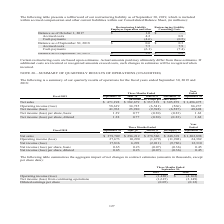According to Cubic's financial document, Where is the restructuring liability included within? accrued compensation and other current liabilities within our Consolidated Balance Sheet, (in millions). The document states: "as of September 30, 2019, which is included within accrued compensation and other current liabilities within our Consolidated Balance Sheet, (in milli..." Also, What is the  Balance as of October 1, 2017 for Restructuring Liability Employee Separation and other? According to the financial document, $ 1.0 (in millions). The relevant text states: "Balance as of October 1, 2017 $ 1.0 $ —..." Also, Which elements of restructuring liability are considered in the table? The document shows two values: Employee Separation and other and Consulting Costs. From the document: "ructuring Liability Employee Separation and other Consulting Costs Restructuring Liability Restructuring Liability Employee Separation and other Consu..." Also, can you calculate: What is the change in balance as of September 30, 2019 from September 30, 2018 for Restructuring Liability Consulting Costs? Based on the calculation: 0.8-0.3, the result is 0.5 (in millions). This is based on the information: "6) (0.5) Balance as of September 30, 2018 $ 0.6 $ 0.3 Accrued costs 4.2 0.8..." The key data points involved are: 0.3, 0.8. Also, can you calculate: What is the change in balance as of September 30, 2019 from September 30, 2018 for Restructuring Liability Employee Separation and other? Based on the calculation: 2.0-0.6, the result is 1.4 (in millions). This is based on the information: "Balance as of September 30, 2019 $ 2.0 $ 0.8 ts (4.6) (0.5) Balance as of September 30, 2018 $ 0.6 $ 0.3..." The key data points involved are: 0.6, 2.0. Also, can you calculate: What is the percentage change in balance as of September 30, 2019 from September 30, 2018 for Restructuring Liability Consulting Costs? To answer this question, I need to perform calculations using the financial data. The calculation is: (0.8-0.3)/0.3, which equals 166.67 (percentage). This is based on the information: "6) (0.5) Balance as of September 30, 2018 $ 0.6 $ 0.3 Accrued costs 4.2 0.8..." The key data points involved are: 0.3, 0.8. 